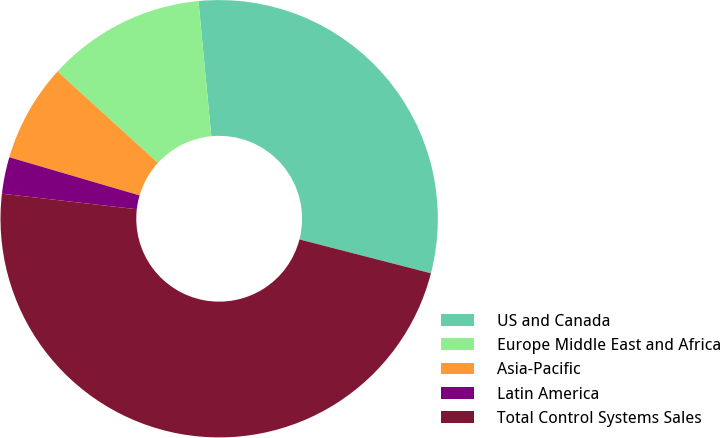Convert chart. <chart><loc_0><loc_0><loc_500><loc_500><pie_chart><fcel>US and Canada<fcel>Europe Middle East and Africa<fcel>Asia-Pacific<fcel>Latin America<fcel>Total Control Systems Sales<nl><fcel>30.52%<fcel>11.73%<fcel>7.22%<fcel>2.71%<fcel>47.81%<nl></chart> 